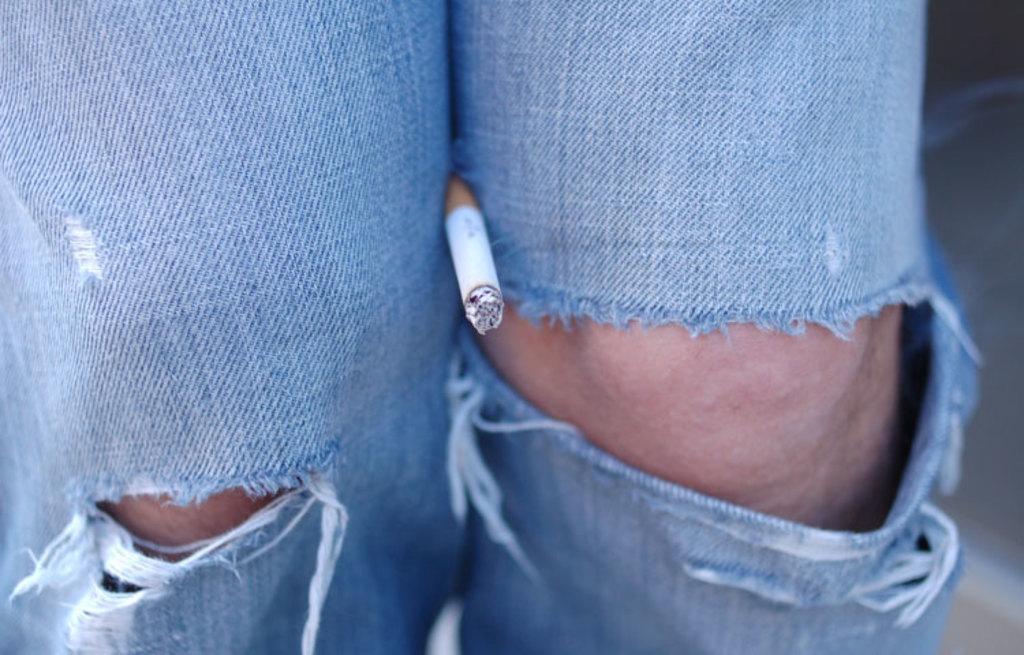Can you describe this image briefly? In this image we can see there is a cigarette placed in between the knee of a person. 